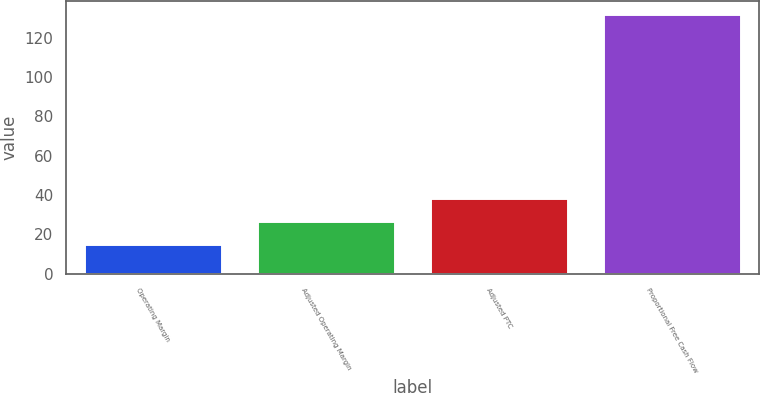Convert chart to OTSL. <chart><loc_0><loc_0><loc_500><loc_500><bar_chart><fcel>Operating Margin<fcel>Adjusted Operating Margin<fcel>Adjusted PTC<fcel>Proportional Free Cash Flow<nl><fcel>15<fcel>26.7<fcel>38.4<fcel>132<nl></chart> 